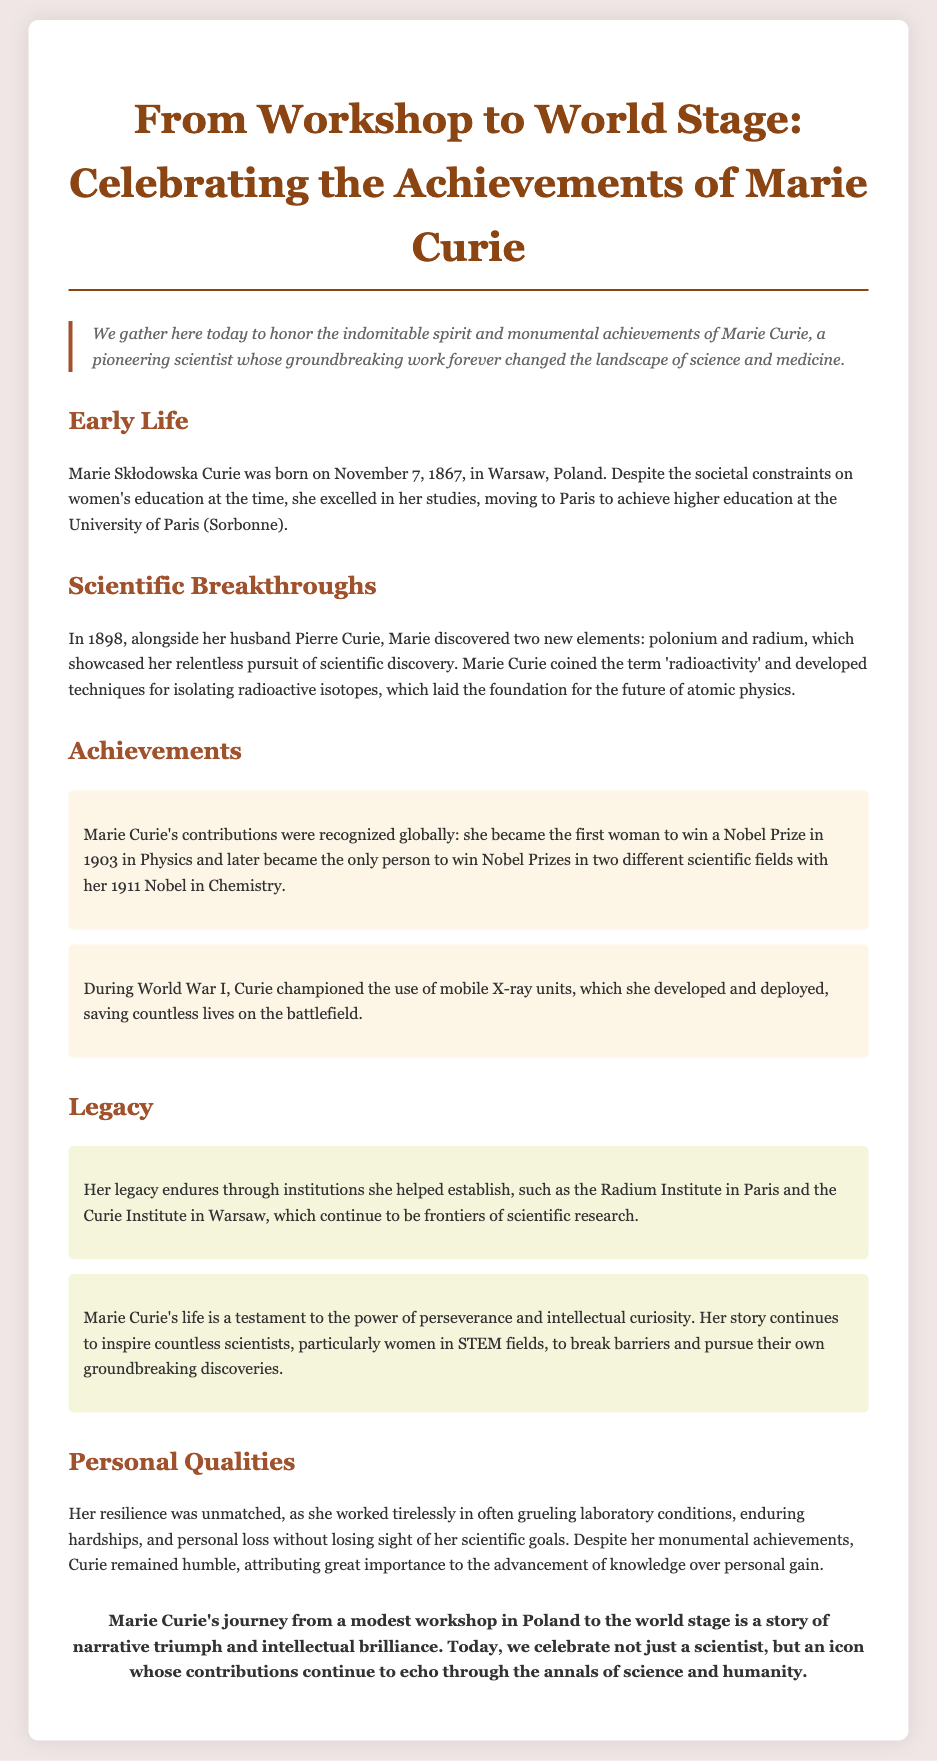what date was Marie Curie born? The document states that Marie Curie was born on November 7, 1867.
Answer: November 7, 1867 who was Marie Curie's husband? The document mentions that she discovered polonium and radium alongside her husband Pierre Curie.
Answer: Pierre Curie how many Nobel Prizes did Marie Curie win? The document indicates that she won Nobel Prizes in two different scientific fields.
Answer: two what is the name of the institute established by Curie in Paris? The document mentions the Radium Institute in Paris as one of the institutions she helped establish.
Answer: Radium Institute why is Marie Curie considered an icon? The document highlights her contributions that continue to inspire countless scientists, particularly women in STEM fields.
Answer: inspiring scientists what personal quality is emphasized in the document about Marie Curie? The document emphasizes her resilience as she worked tirelessly in often grueling laboratory conditions.
Answer: resilience what scientific term did Marie Curie coin? The document states that she coined the term 'radioactivity'.
Answer: radioactivity 